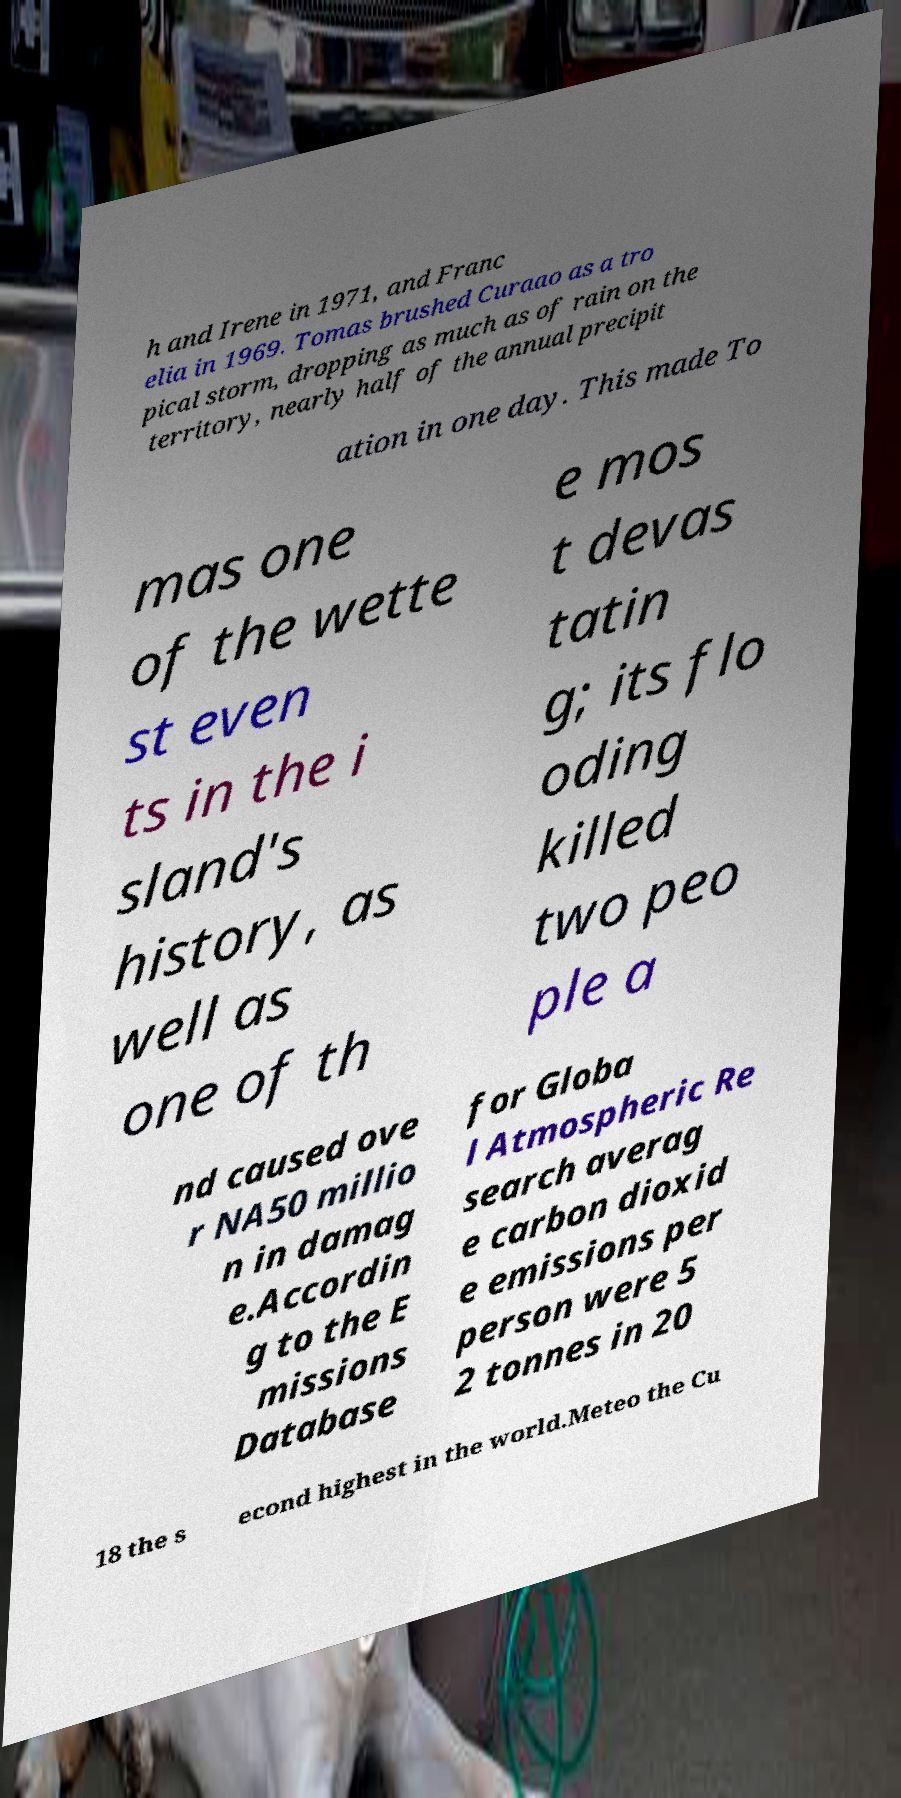Can you accurately transcribe the text from the provided image for me? h and Irene in 1971, and Franc elia in 1969. Tomas brushed Curaao as a tro pical storm, dropping as much as of rain on the territory, nearly half of the annual precipit ation in one day. This made To mas one of the wette st even ts in the i sland's history, as well as one of th e mos t devas tatin g; its flo oding killed two peo ple a nd caused ove r NA50 millio n in damag e.Accordin g to the E missions Database for Globa l Atmospheric Re search averag e carbon dioxid e emissions per person were 5 2 tonnes in 20 18 the s econd highest in the world.Meteo the Cu 